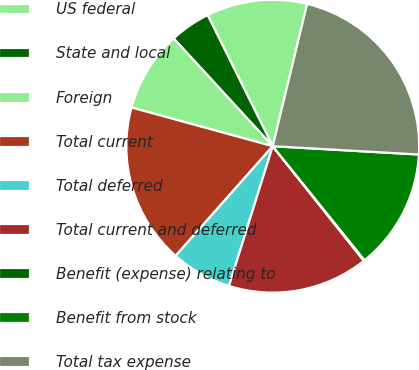Convert chart to OTSL. <chart><loc_0><loc_0><loc_500><loc_500><pie_chart><fcel>US federal<fcel>State and local<fcel>Foreign<fcel>Total current<fcel>Total deferred<fcel>Total current and deferred<fcel>Benefit (expense) relating to<fcel>Benefit from stock<fcel>Total tax expense<nl><fcel>11.11%<fcel>4.5%<fcel>8.91%<fcel>17.72%<fcel>6.71%<fcel>15.52%<fcel>0.1%<fcel>13.31%<fcel>22.13%<nl></chart> 